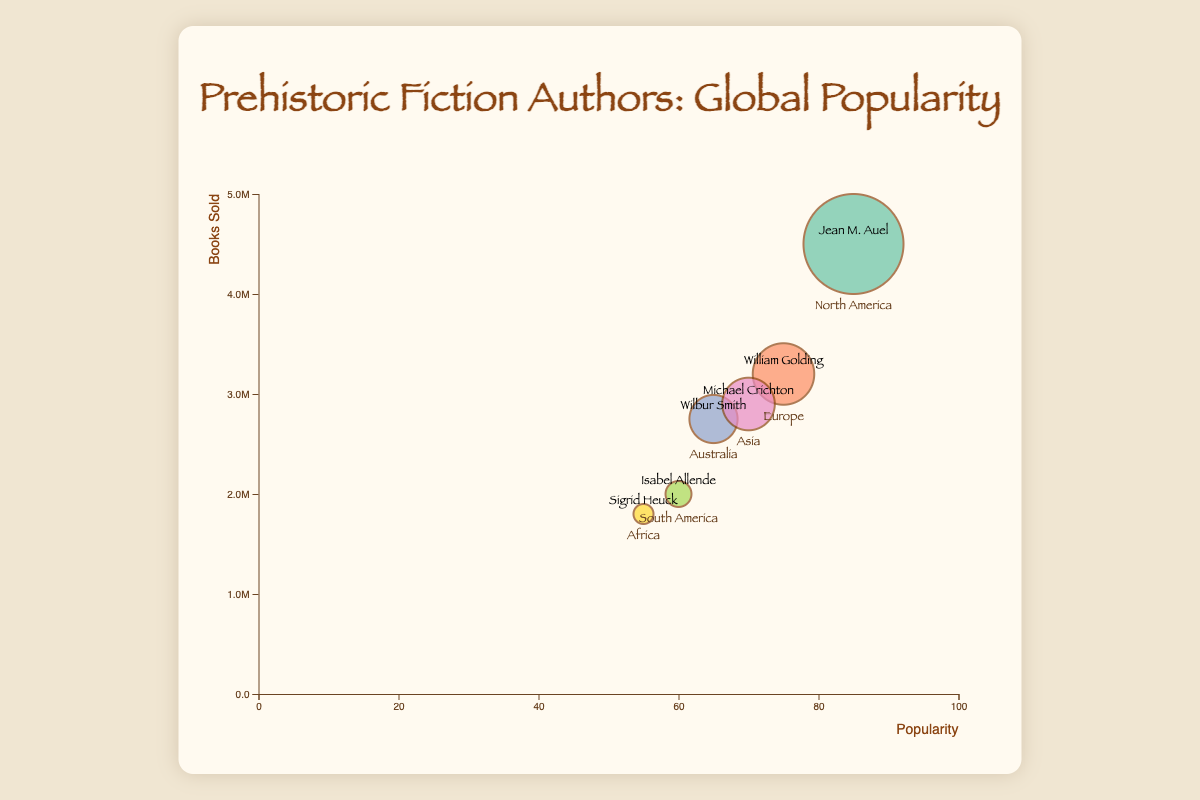Which continent features the most popular author according to the chart? By looking at the x-axis of the chart, which represents the popularity, the author with the highest value is on the far right. Jean M. Auel, with a popularity of 85, is the highest, which places her in North America.
Answer: North America What's the title of the chart? The title of the chart is prominently displayed at the top of the chart.
Answer: Prehistoric Fiction Authors: Global Popularity How many authors are depicted in the chart? Each bubble in the chart represents an author, and since there are six bubbles, there are six authors.
Answer: Six Which author has sold the most books, and how many? The y-axis of the chart represents the number of books sold, and the author whose bubble reaches the highest value on this axis has sold the most books. Jean M. Auel's bubble is the highest, indicating she has sold 4,500,000 books.
Answer: Jean M. Auel, 4,500,000 Compare the popularity of William Golding and Isabel Allende. Which one is more popular and by how much? William Golding is shown with a popularity of 75, while Isabel Allende has a popularity of 60. The difference in their popularity is 75 - 60 = 15.
Answer: William Golding, 15 What is the range of the popularity values represented in the chart? The range is the difference between the highest and lowest popularity values. The highest is 85 (Jean M. Auel) and the lowest is 55 (Sigrid Heuck). So, the range is 85 - 55 = 30.
Answer: 30 Identify the author from Asia and mention their popularity. The label "Asia" on a bubble, along with the attached author's name, is Michael Crichton. His popularity is represented as 70.
Answer: Michael Crichton, 70 If we multiply the popularity of Wilbur Smith by the popularity of Sigrid Heuck, what is the result? Wilbur Smith has a popularity of 65, and Sigrid Heuck has a popularity of 55. Multiplying these gives 65 * 55 = 3575.
Answer: 3575 Which author has the smallest bubble, and what does this represent? The smallest bubble on the chart represents the author who has sold the least number of books. Sigrid Heuck's bubble is the smallest, indicating she has sold 1,800,000 books.
Answer: Sigrid Heuck, smallest number of books sold 